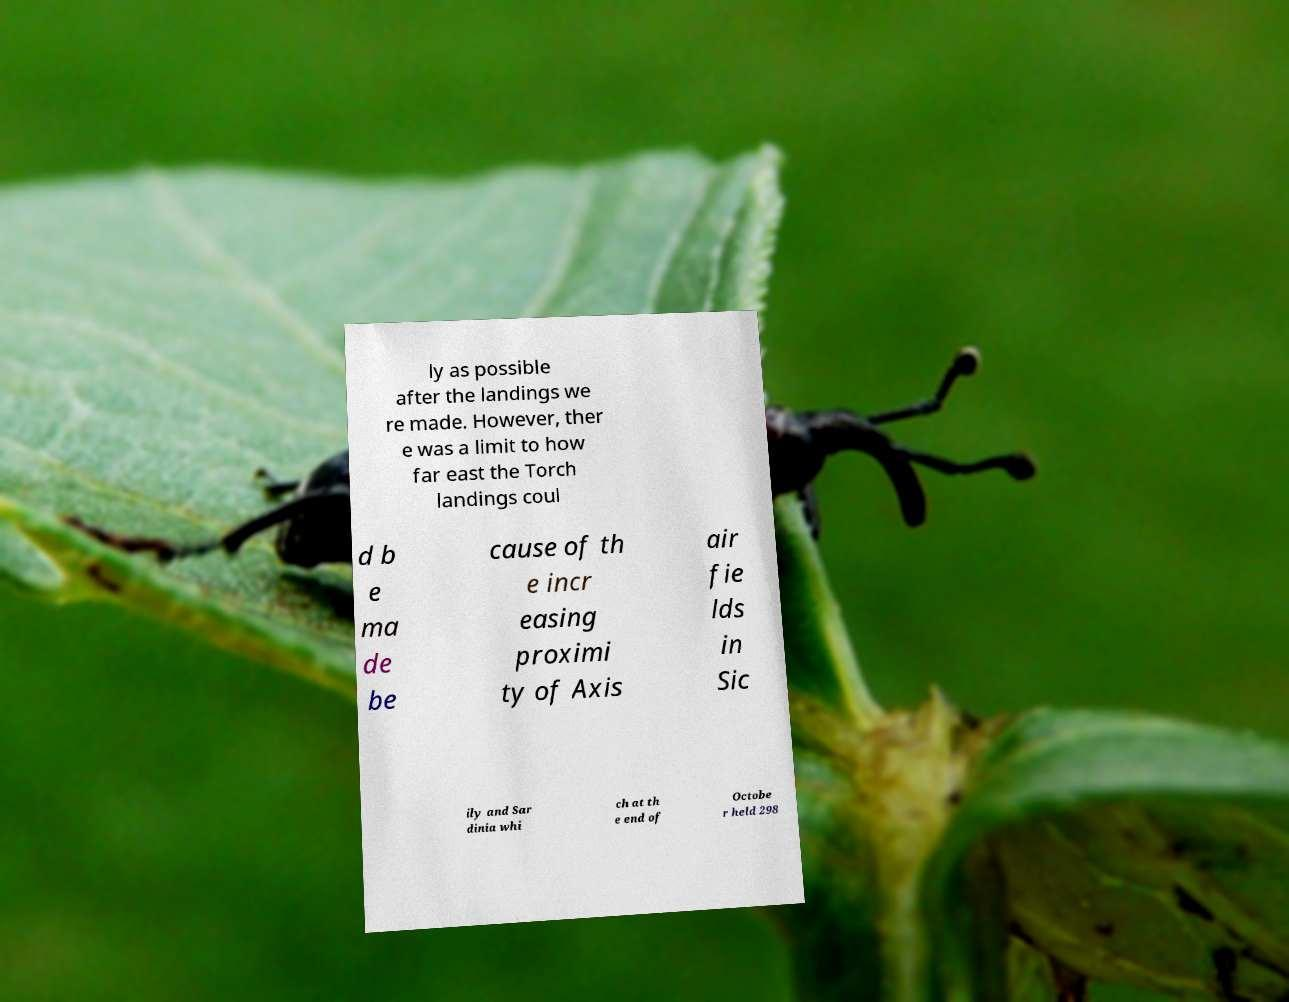There's text embedded in this image that I need extracted. Can you transcribe it verbatim? ly as possible after the landings we re made. However, ther e was a limit to how far east the Torch landings coul d b e ma de be cause of th e incr easing proximi ty of Axis air fie lds in Sic ily and Sar dinia whi ch at th e end of Octobe r held 298 